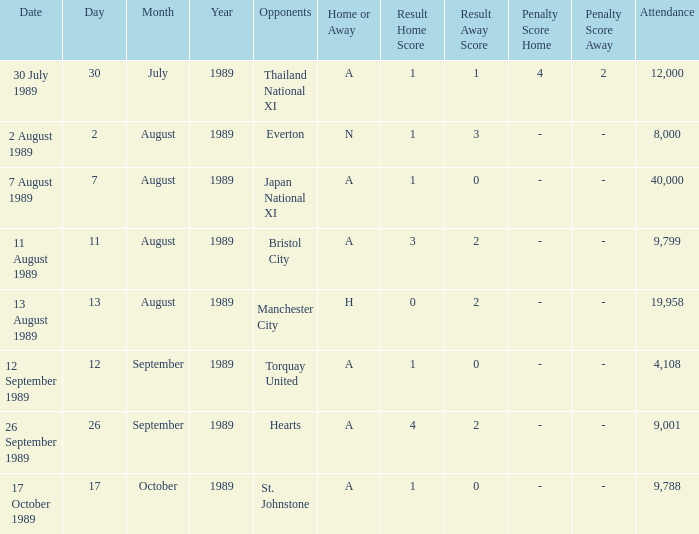When did Manchester United play against Bristol City with an H/A of A? 11 August 1989. Would you be able to parse every entry in this table? {'header': ['Date', 'Day', 'Month', 'Year', 'Opponents', 'Home or Away', 'Result Home Score', 'Result Away Score', 'Penalty Score Home', 'Penalty Score Away', 'Attendance'], 'rows': [['30 July 1989', '30', 'July', '1989', 'Thailand National XI', 'A', '1', '1', '4', '2', '12,000'], ['2 August 1989', '2', 'August', '1989', 'Everton', 'N', '1', '3', '-', '-', '8,000'], ['7 August 1989', '7', 'August', '1989', 'Japan National XI', 'A', '1', '0', '-', '-', '40,000'], ['11 August 1989', '11', 'August', '1989', 'Bristol City', 'A', '3', '2', '-', '-', '9,799'], ['13 August 1989', '13', 'August', '1989', 'Manchester City', 'H', '0', '2', '-', '-', '19,958'], ['12 September 1989', '12', 'September', '1989', 'Torquay United', 'A', '1', '0', '-', '-', '4,108'], ['26 September 1989', '26', 'September', '1989', 'Hearts', 'A', '4', '2', '-', '-', '9,001'], ['17 October 1989', '17', 'October', '1989', 'St. Johnstone', 'A', '1', '0', '-', '-', '9,788']]} 